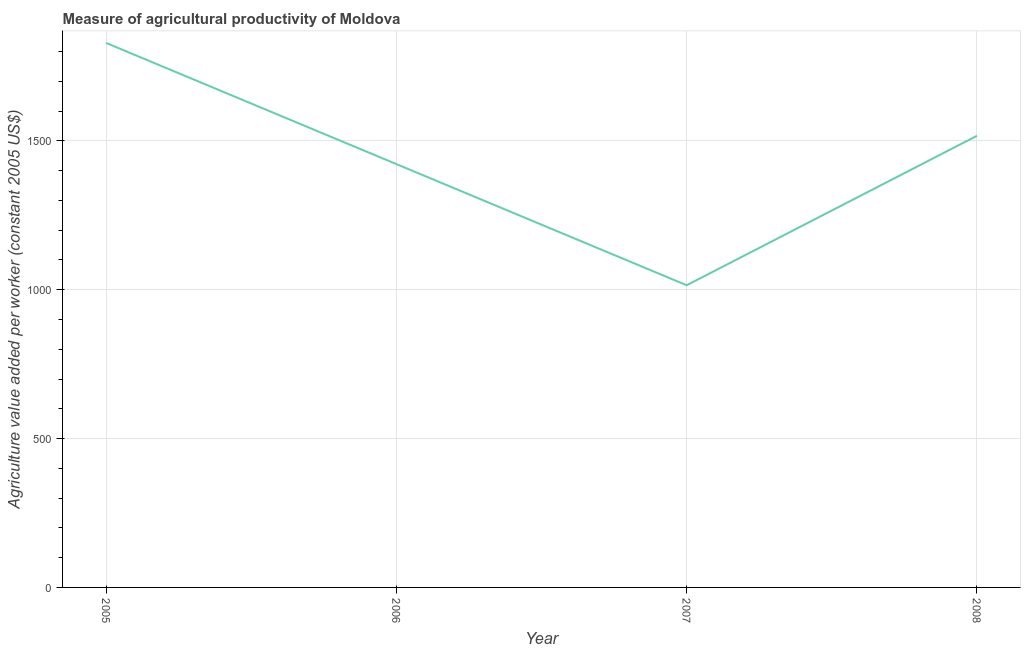What is the agriculture value added per worker in 2008?
Offer a terse response. 1516.87. Across all years, what is the maximum agriculture value added per worker?
Your answer should be very brief. 1828.67. Across all years, what is the minimum agriculture value added per worker?
Provide a succinct answer. 1014.86. In which year was the agriculture value added per worker maximum?
Offer a terse response. 2005. In which year was the agriculture value added per worker minimum?
Your answer should be very brief. 2007. What is the sum of the agriculture value added per worker?
Your response must be concise. 5782.17. What is the difference between the agriculture value added per worker in 2006 and 2008?
Make the answer very short. -95.1. What is the average agriculture value added per worker per year?
Give a very brief answer. 1445.54. What is the median agriculture value added per worker?
Give a very brief answer. 1469.32. In how many years, is the agriculture value added per worker greater than 1500 US$?
Make the answer very short. 2. What is the ratio of the agriculture value added per worker in 2006 to that in 2007?
Offer a terse response. 1.4. What is the difference between the highest and the second highest agriculture value added per worker?
Provide a succinct answer. 311.79. Is the sum of the agriculture value added per worker in 2005 and 2006 greater than the maximum agriculture value added per worker across all years?
Offer a very short reply. Yes. What is the difference between the highest and the lowest agriculture value added per worker?
Give a very brief answer. 813.81. In how many years, is the agriculture value added per worker greater than the average agriculture value added per worker taken over all years?
Provide a short and direct response. 2. Does the agriculture value added per worker monotonically increase over the years?
Offer a terse response. No. Does the graph contain any zero values?
Offer a very short reply. No. What is the title of the graph?
Your answer should be compact. Measure of agricultural productivity of Moldova. What is the label or title of the X-axis?
Your answer should be compact. Year. What is the label or title of the Y-axis?
Provide a succinct answer. Agriculture value added per worker (constant 2005 US$). What is the Agriculture value added per worker (constant 2005 US$) in 2005?
Your answer should be very brief. 1828.67. What is the Agriculture value added per worker (constant 2005 US$) of 2006?
Provide a short and direct response. 1421.78. What is the Agriculture value added per worker (constant 2005 US$) of 2007?
Make the answer very short. 1014.86. What is the Agriculture value added per worker (constant 2005 US$) of 2008?
Your answer should be compact. 1516.87. What is the difference between the Agriculture value added per worker (constant 2005 US$) in 2005 and 2006?
Your answer should be compact. 406.89. What is the difference between the Agriculture value added per worker (constant 2005 US$) in 2005 and 2007?
Your response must be concise. 813.81. What is the difference between the Agriculture value added per worker (constant 2005 US$) in 2005 and 2008?
Provide a short and direct response. 311.79. What is the difference between the Agriculture value added per worker (constant 2005 US$) in 2006 and 2007?
Give a very brief answer. 406.92. What is the difference between the Agriculture value added per worker (constant 2005 US$) in 2006 and 2008?
Keep it short and to the point. -95.1. What is the difference between the Agriculture value added per worker (constant 2005 US$) in 2007 and 2008?
Your answer should be compact. -502.02. What is the ratio of the Agriculture value added per worker (constant 2005 US$) in 2005 to that in 2006?
Provide a short and direct response. 1.29. What is the ratio of the Agriculture value added per worker (constant 2005 US$) in 2005 to that in 2007?
Your answer should be very brief. 1.8. What is the ratio of the Agriculture value added per worker (constant 2005 US$) in 2005 to that in 2008?
Provide a succinct answer. 1.21. What is the ratio of the Agriculture value added per worker (constant 2005 US$) in 2006 to that in 2007?
Your answer should be compact. 1.4. What is the ratio of the Agriculture value added per worker (constant 2005 US$) in 2006 to that in 2008?
Offer a very short reply. 0.94. What is the ratio of the Agriculture value added per worker (constant 2005 US$) in 2007 to that in 2008?
Give a very brief answer. 0.67. 